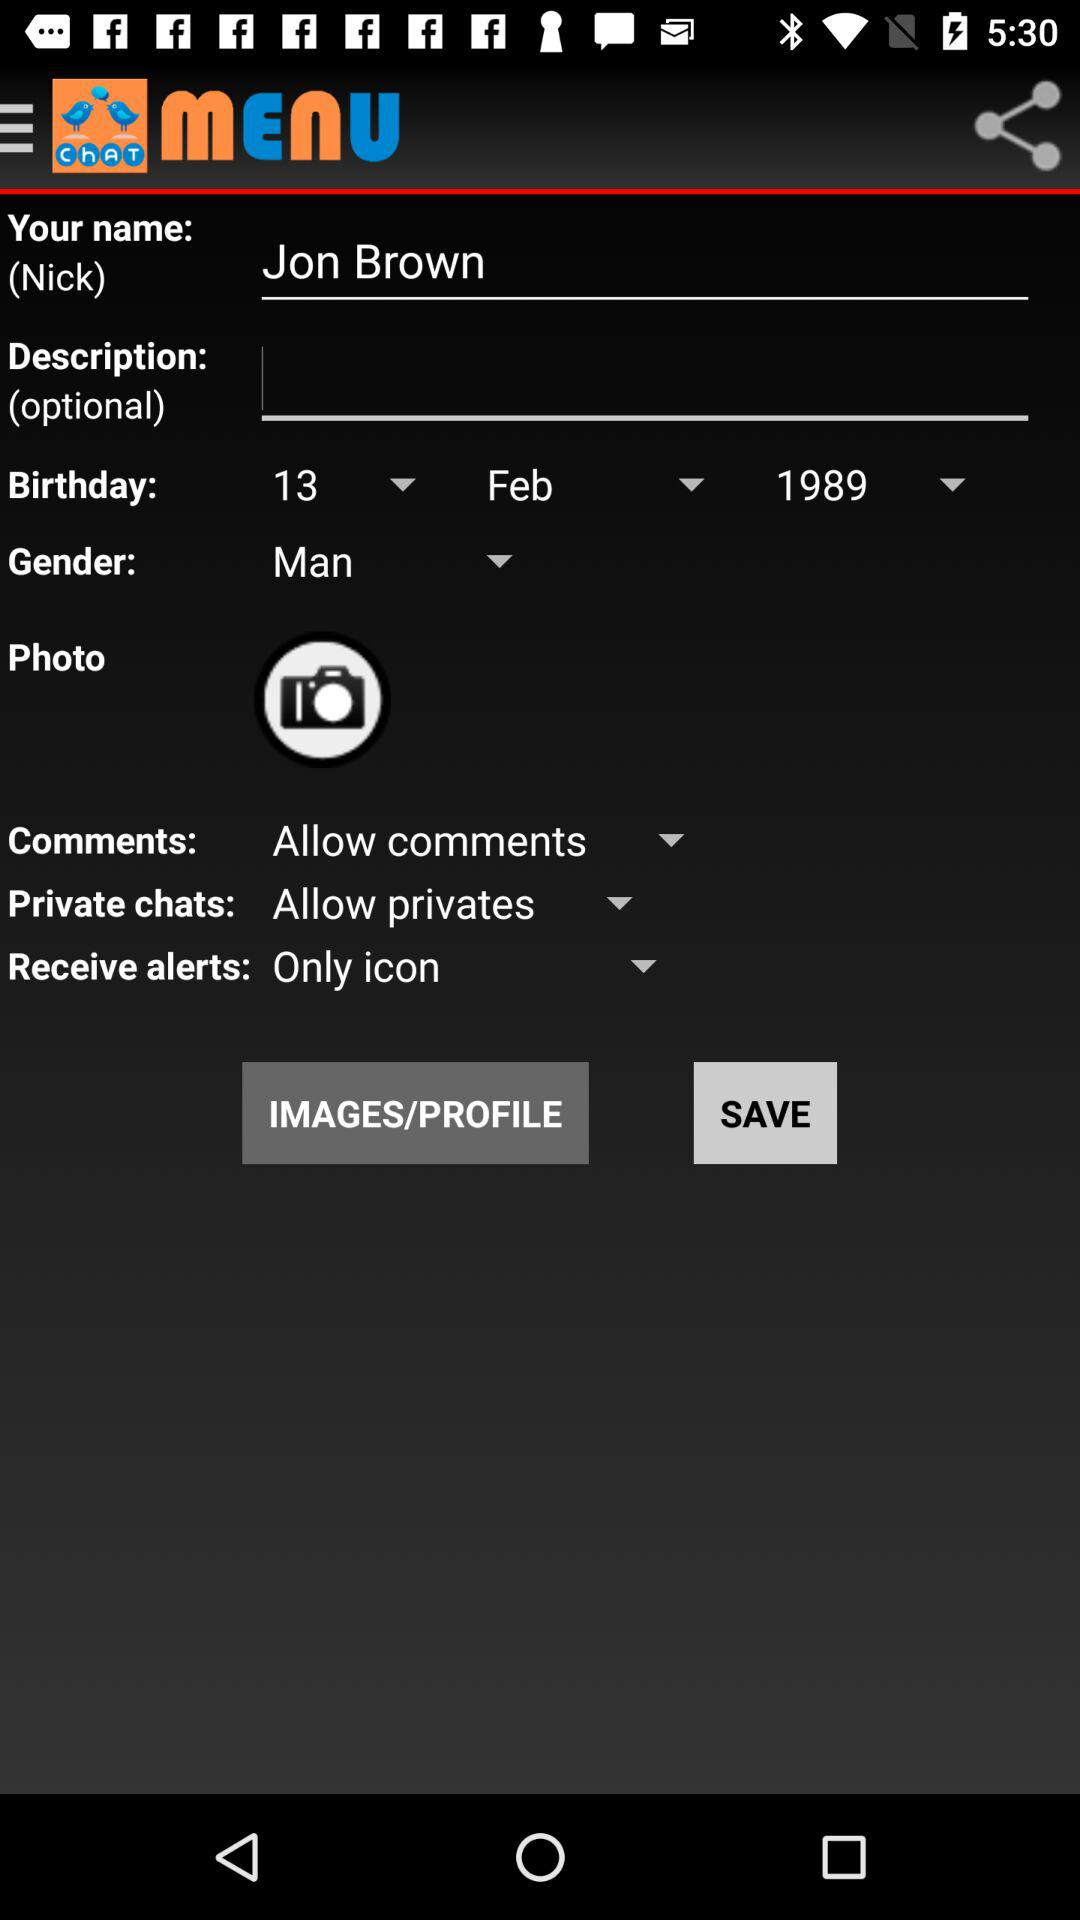What is the selected birth date? The selected birth date is February 13, 1989. 